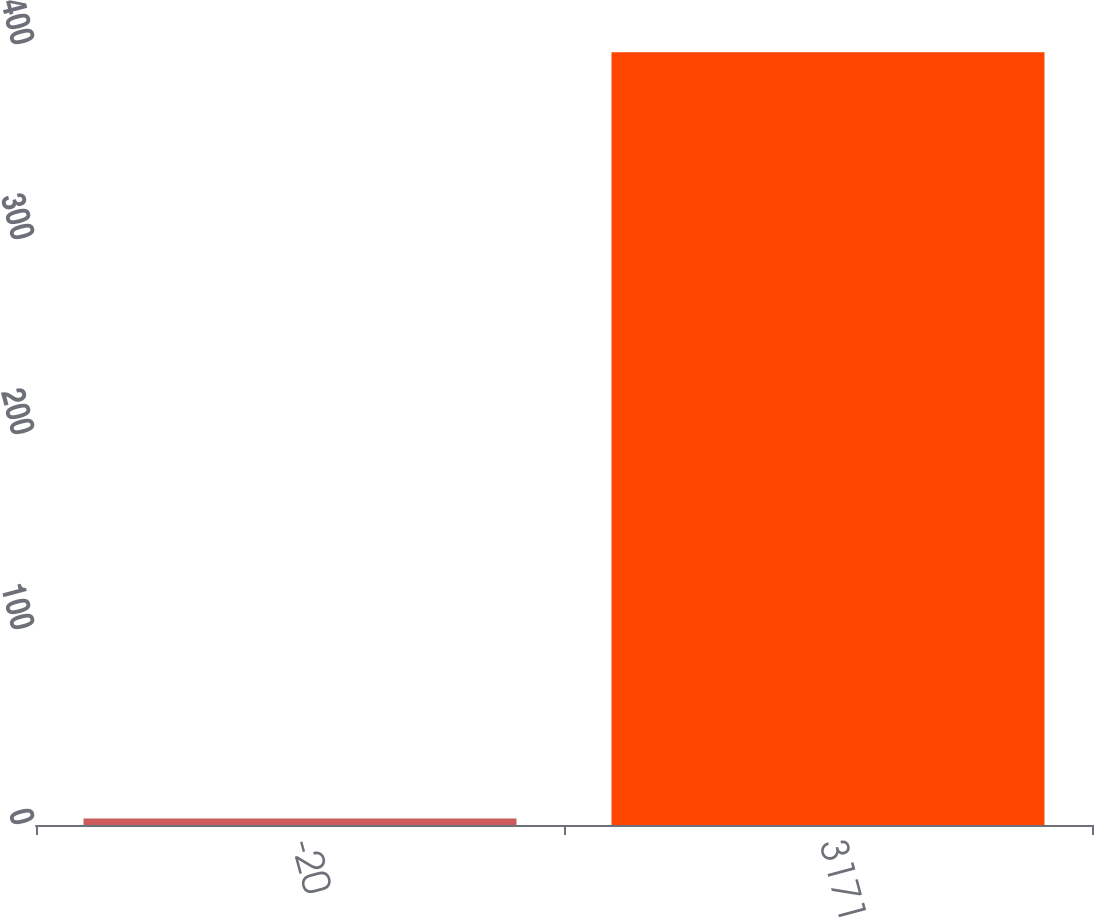<chart> <loc_0><loc_0><loc_500><loc_500><bar_chart><fcel>-20<fcel>3171<nl><fcel>3.34<fcel>396.3<nl></chart> 